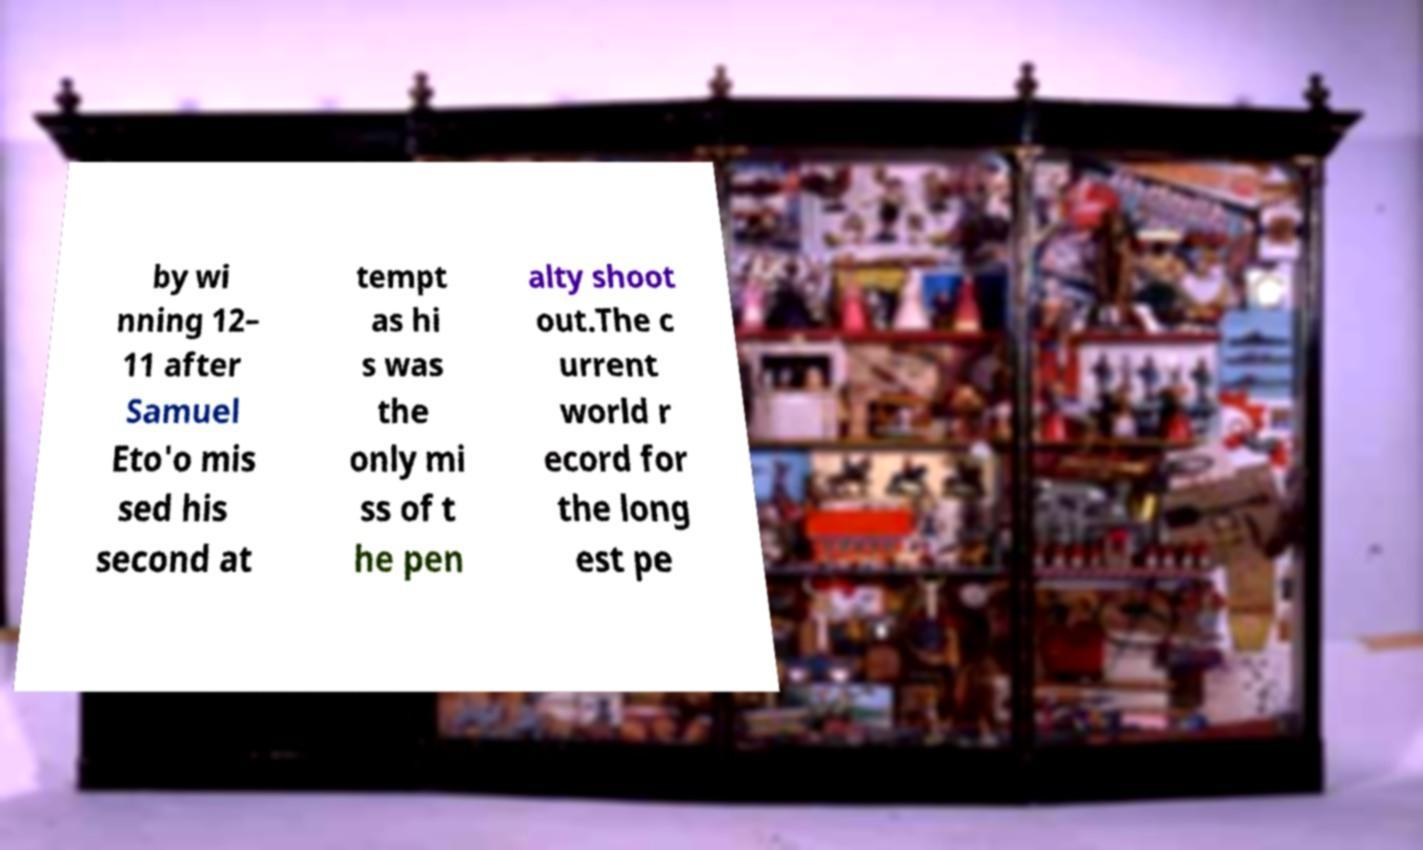Please identify and transcribe the text found in this image. by wi nning 12– 11 after Samuel Eto'o mis sed his second at tempt as hi s was the only mi ss of t he pen alty shoot out.The c urrent world r ecord for the long est pe 